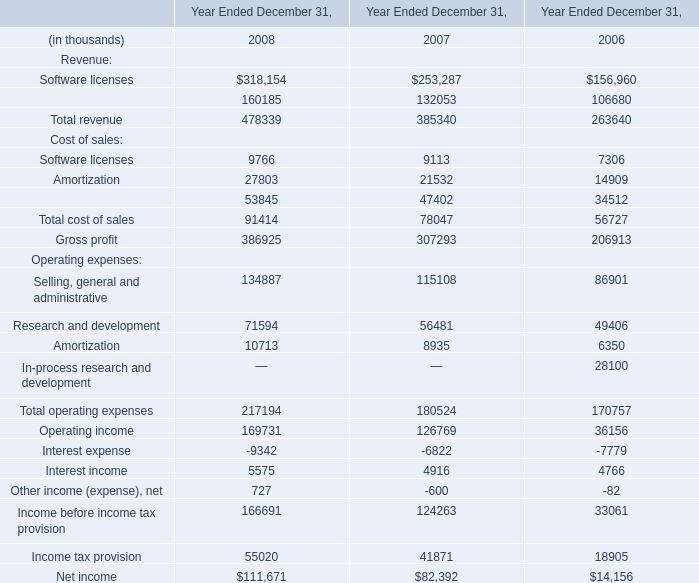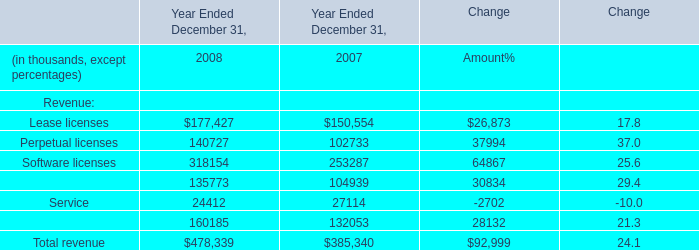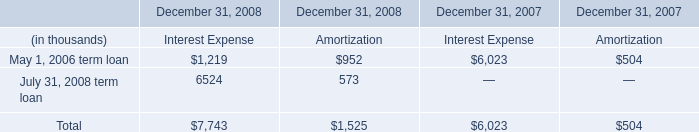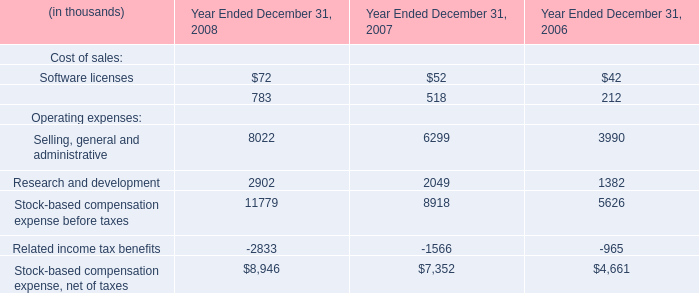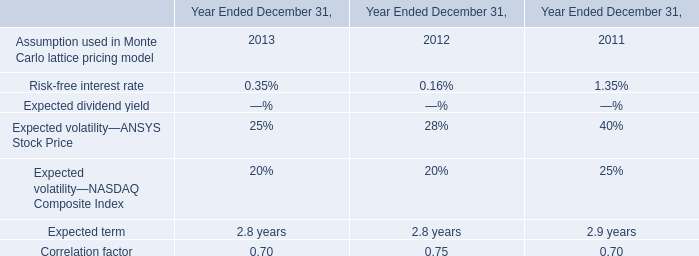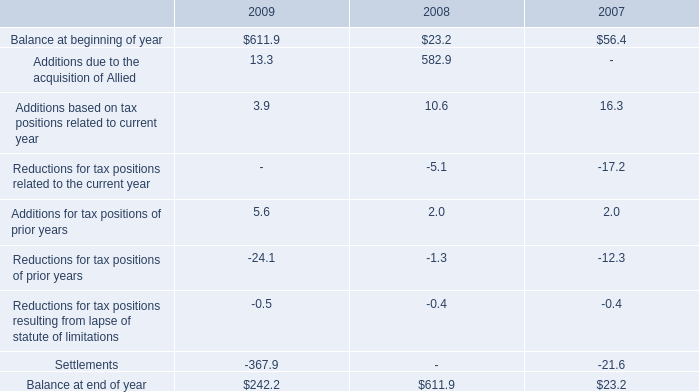What's the total amount of Lease licenses,Perpetual licenses,Software licenses and Maintenance in 2008? (in thousand) 
Computations: (((177427 + 140727) + 318154) + 135773)
Answer: 772081.0. 